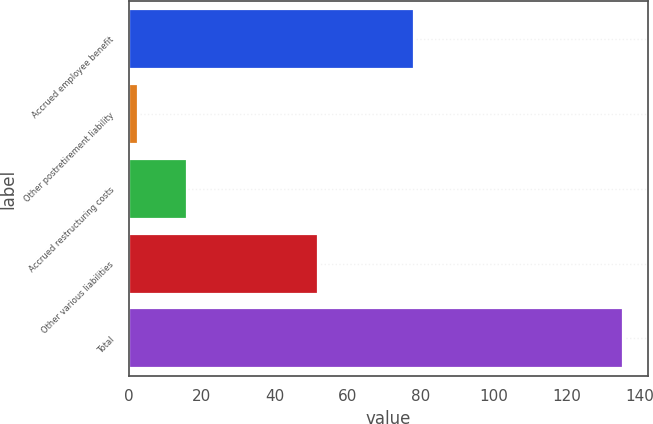Convert chart. <chart><loc_0><loc_0><loc_500><loc_500><bar_chart><fcel>Accrued employee benefit<fcel>Other postretirement liability<fcel>Accrued restructuring costs<fcel>Other various liabilities<fcel>Total<nl><fcel>78.1<fcel>2.5<fcel>15.81<fcel>51.8<fcel>135.6<nl></chart> 